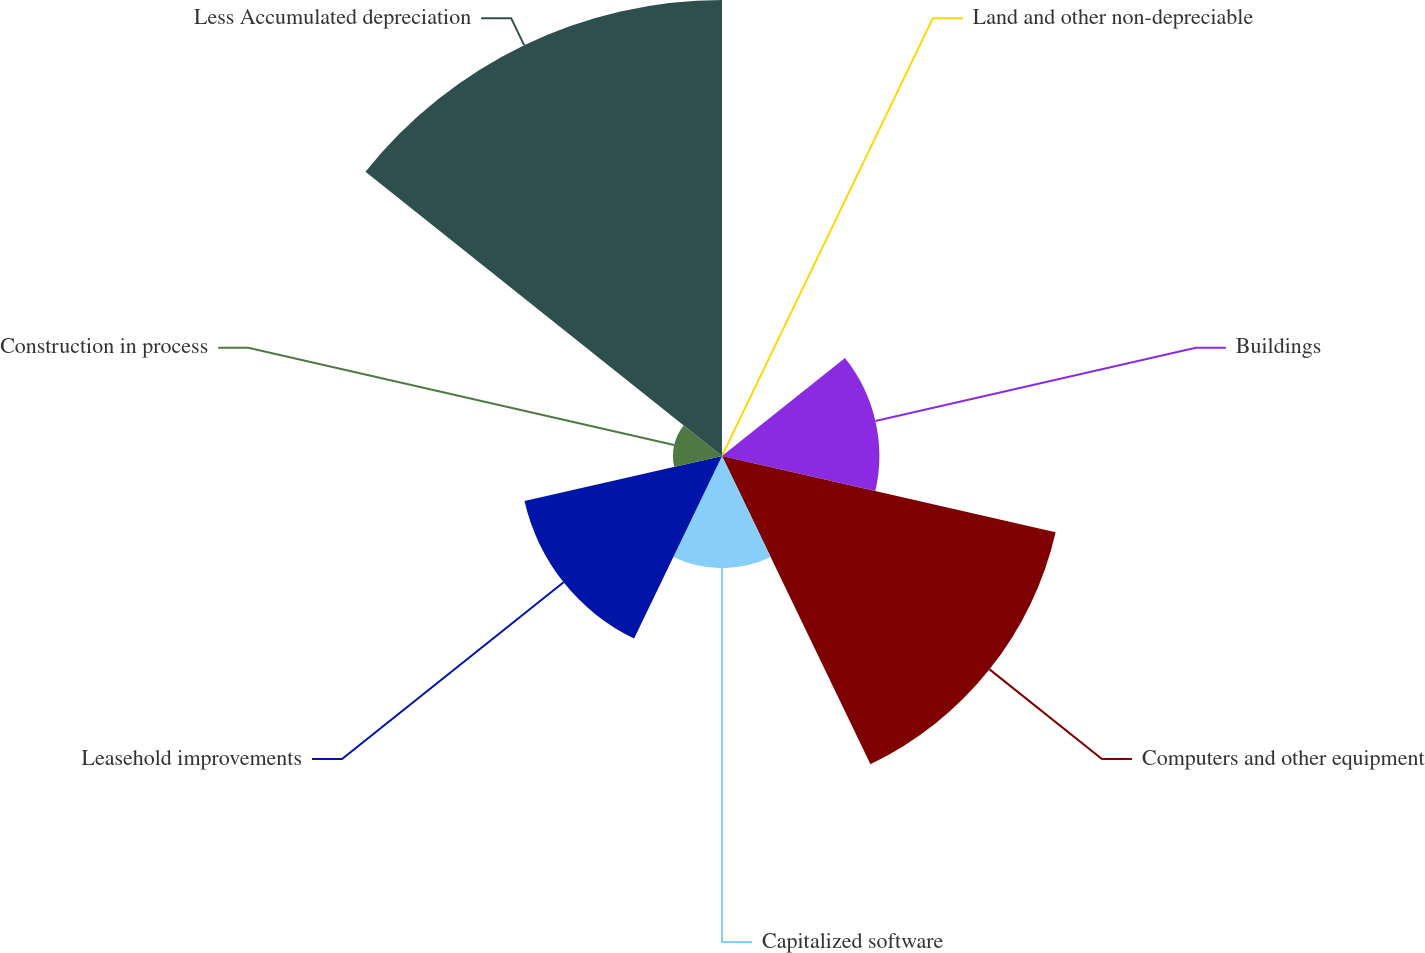Convert chart to OTSL. <chart><loc_0><loc_0><loc_500><loc_500><pie_chart><fcel>Land and other non-depreciable<fcel>Buildings<fcel>Computers and other equipment<fcel>Capitalized software<fcel>Leasehold improvements<fcel>Construction in process<fcel>Less Accumulated depreciation<nl><fcel>0.3%<fcel>11.89%<fcel>25.86%<fcel>8.48%<fcel>15.31%<fcel>3.71%<fcel>34.46%<nl></chart> 